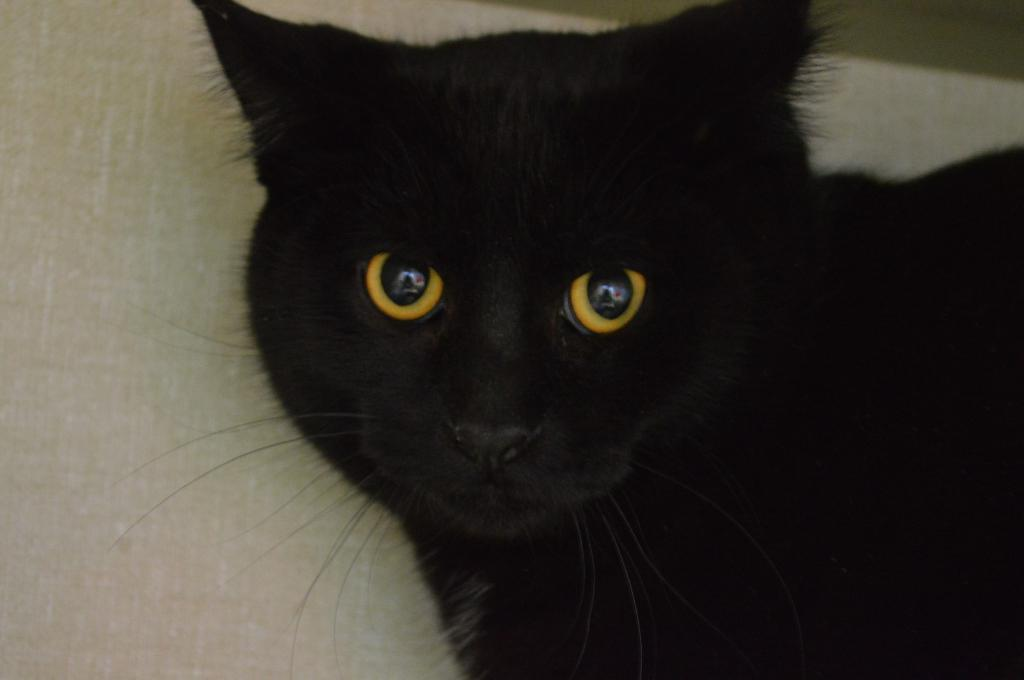What type of animal is in the image? There is a black cat in the image. What can be seen behind the cat in the image? There is a background visible in the image. What type of credit card is the cat holding in the image? There is no credit card present in the image; it only features a black cat. 